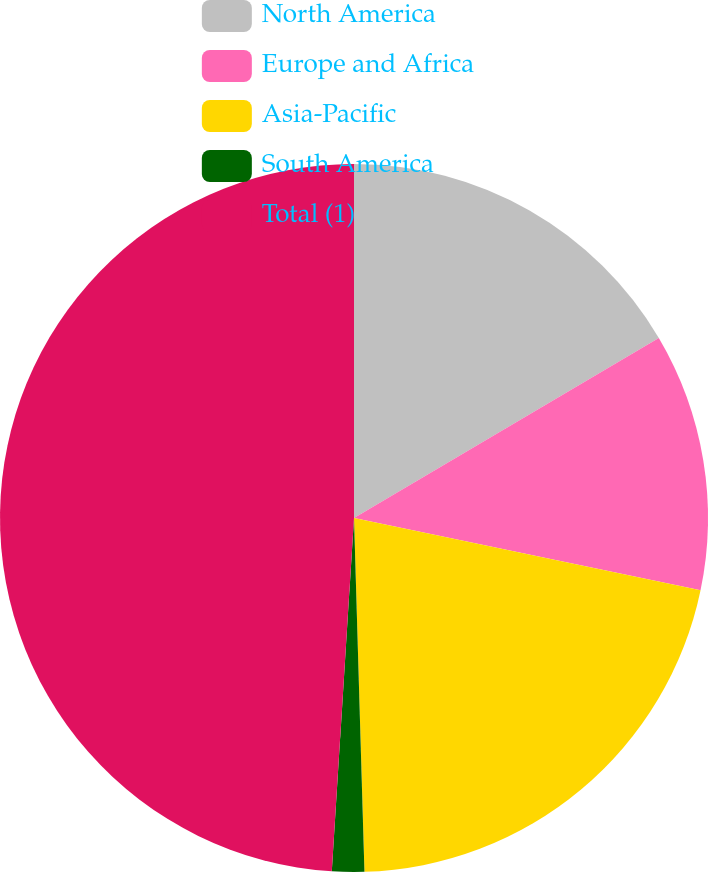Convert chart to OTSL. <chart><loc_0><loc_0><loc_500><loc_500><pie_chart><fcel>North America<fcel>Europe and Africa<fcel>Asia-Pacific<fcel>South America<fcel>Total (1)<nl><fcel>16.51%<fcel>11.76%<fcel>21.26%<fcel>1.47%<fcel>49.0%<nl></chart> 